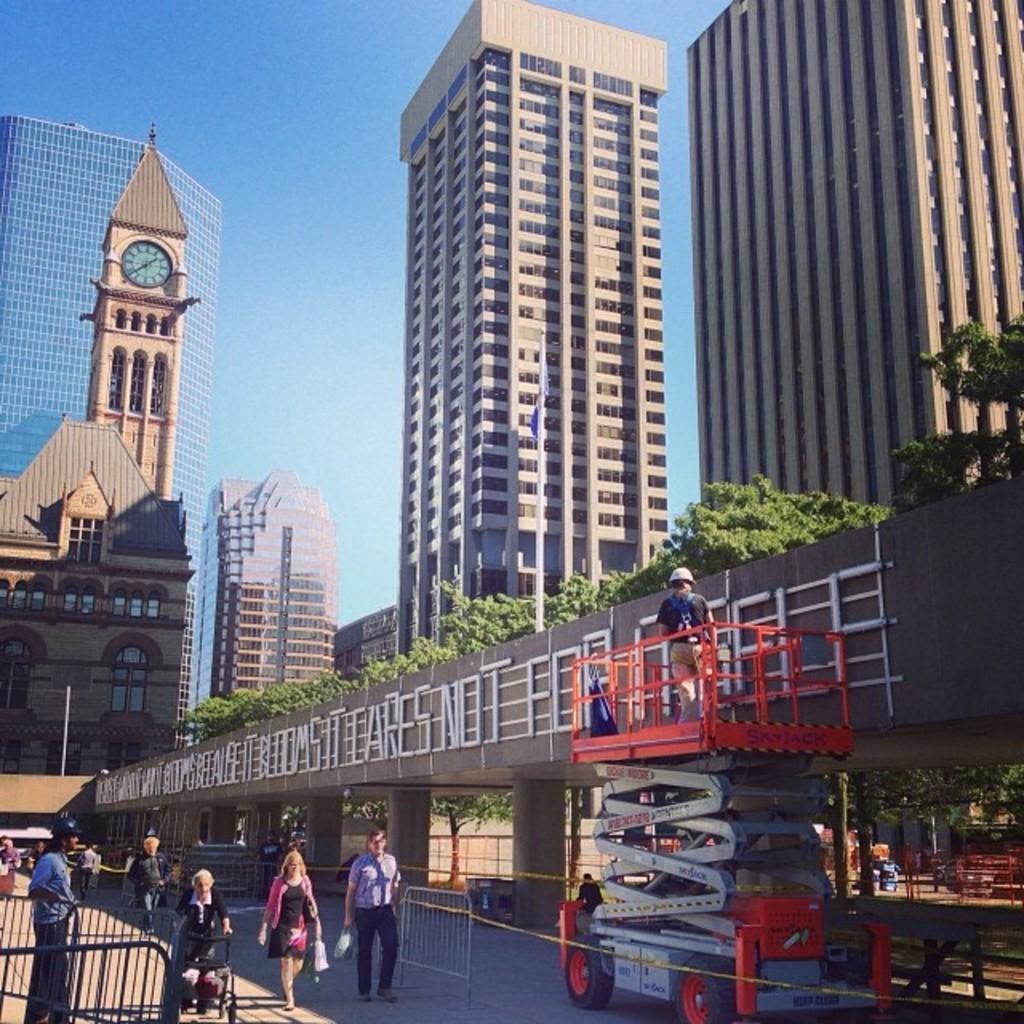Can you describe this image briefly? In this image we can see buildings, trees, barrier grills, person walking on the road, person standing on the motor vehicle and sly. 